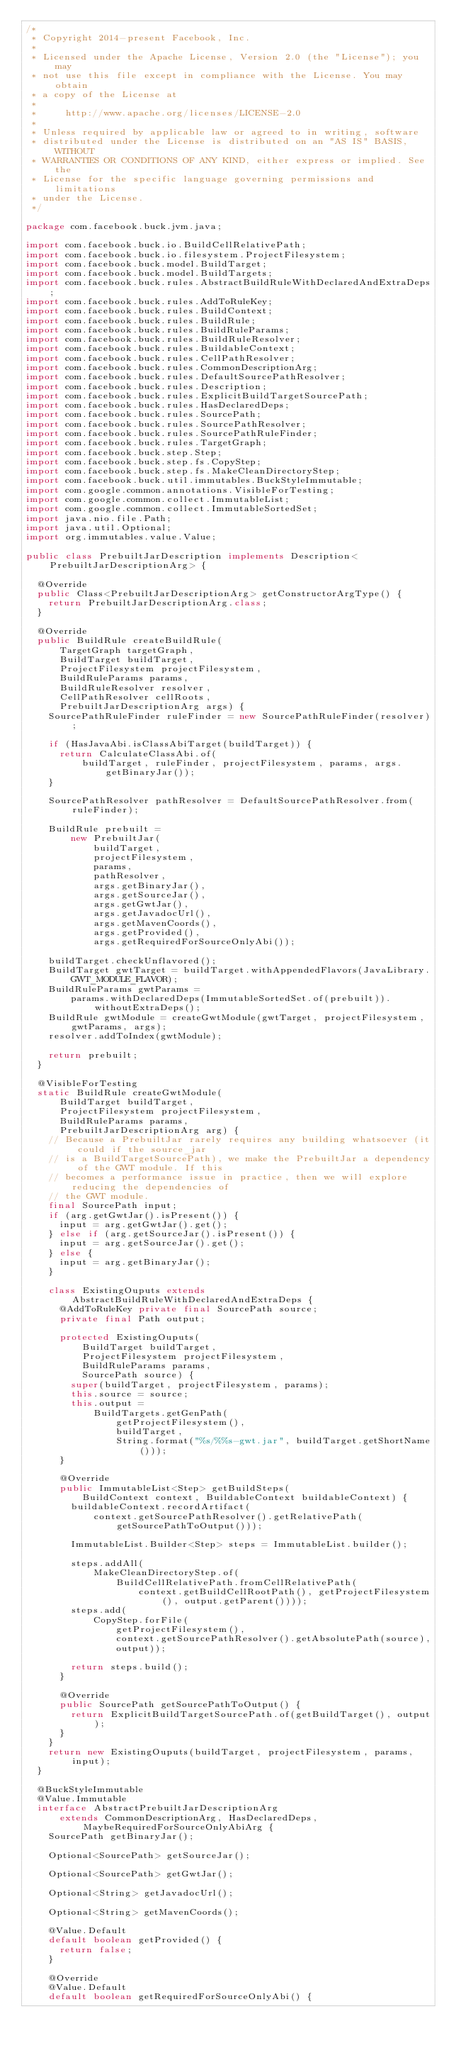Convert code to text. <code><loc_0><loc_0><loc_500><loc_500><_Java_>/*
 * Copyright 2014-present Facebook, Inc.
 *
 * Licensed under the Apache License, Version 2.0 (the "License"); you may
 * not use this file except in compliance with the License. You may obtain
 * a copy of the License at
 *
 *     http://www.apache.org/licenses/LICENSE-2.0
 *
 * Unless required by applicable law or agreed to in writing, software
 * distributed under the License is distributed on an "AS IS" BASIS, WITHOUT
 * WARRANTIES OR CONDITIONS OF ANY KIND, either express or implied. See the
 * License for the specific language governing permissions and limitations
 * under the License.
 */

package com.facebook.buck.jvm.java;

import com.facebook.buck.io.BuildCellRelativePath;
import com.facebook.buck.io.filesystem.ProjectFilesystem;
import com.facebook.buck.model.BuildTarget;
import com.facebook.buck.model.BuildTargets;
import com.facebook.buck.rules.AbstractBuildRuleWithDeclaredAndExtraDeps;
import com.facebook.buck.rules.AddToRuleKey;
import com.facebook.buck.rules.BuildContext;
import com.facebook.buck.rules.BuildRule;
import com.facebook.buck.rules.BuildRuleParams;
import com.facebook.buck.rules.BuildRuleResolver;
import com.facebook.buck.rules.BuildableContext;
import com.facebook.buck.rules.CellPathResolver;
import com.facebook.buck.rules.CommonDescriptionArg;
import com.facebook.buck.rules.DefaultSourcePathResolver;
import com.facebook.buck.rules.Description;
import com.facebook.buck.rules.ExplicitBuildTargetSourcePath;
import com.facebook.buck.rules.HasDeclaredDeps;
import com.facebook.buck.rules.SourcePath;
import com.facebook.buck.rules.SourcePathResolver;
import com.facebook.buck.rules.SourcePathRuleFinder;
import com.facebook.buck.rules.TargetGraph;
import com.facebook.buck.step.Step;
import com.facebook.buck.step.fs.CopyStep;
import com.facebook.buck.step.fs.MakeCleanDirectoryStep;
import com.facebook.buck.util.immutables.BuckStyleImmutable;
import com.google.common.annotations.VisibleForTesting;
import com.google.common.collect.ImmutableList;
import com.google.common.collect.ImmutableSortedSet;
import java.nio.file.Path;
import java.util.Optional;
import org.immutables.value.Value;

public class PrebuiltJarDescription implements Description<PrebuiltJarDescriptionArg> {

  @Override
  public Class<PrebuiltJarDescriptionArg> getConstructorArgType() {
    return PrebuiltJarDescriptionArg.class;
  }

  @Override
  public BuildRule createBuildRule(
      TargetGraph targetGraph,
      BuildTarget buildTarget,
      ProjectFilesystem projectFilesystem,
      BuildRuleParams params,
      BuildRuleResolver resolver,
      CellPathResolver cellRoots,
      PrebuiltJarDescriptionArg args) {
    SourcePathRuleFinder ruleFinder = new SourcePathRuleFinder(resolver);

    if (HasJavaAbi.isClassAbiTarget(buildTarget)) {
      return CalculateClassAbi.of(
          buildTarget, ruleFinder, projectFilesystem, params, args.getBinaryJar());
    }

    SourcePathResolver pathResolver = DefaultSourcePathResolver.from(ruleFinder);

    BuildRule prebuilt =
        new PrebuiltJar(
            buildTarget,
            projectFilesystem,
            params,
            pathResolver,
            args.getBinaryJar(),
            args.getSourceJar(),
            args.getGwtJar(),
            args.getJavadocUrl(),
            args.getMavenCoords(),
            args.getProvided(),
            args.getRequiredForSourceOnlyAbi());

    buildTarget.checkUnflavored();
    BuildTarget gwtTarget = buildTarget.withAppendedFlavors(JavaLibrary.GWT_MODULE_FLAVOR);
    BuildRuleParams gwtParams =
        params.withDeclaredDeps(ImmutableSortedSet.of(prebuilt)).withoutExtraDeps();
    BuildRule gwtModule = createGwtModule(gwtTarget, projectFilesystem, gwtParams, args);
    resolver.addToIndex(gwtModule);

    return prebuilt;
  }

  @VisibleForTesting
  static BuildRule createGwtModule(
      BuildTarget buildTarget,
      ProjectFilesystem projectFilesystem,
      BuildRuleParams params,
      PrebuiltJarDescriptionArg arg) {
    // Because a PrebuiltJar rarely requires any building whatsoever (it could if the source_jar
    // is a BuildTargetSourcePath), we make the PrebuiltJar a dependency of the GWT module. If this
    // becomes a performance issue in practice, then we will explore reducing the dependencies of
    // the GWT module.
    final SourcePath input;
    if (arg.getGwtJar().isPresent()) {
      input = arg.getGwtJar().get();
    } else if (arg.getSourceJar().isPresent()) {
      input = arg.getSourceJar().get();
    } else {
      input = arg.getBinaryJar();
    }

    class ExistingOuputs extends AbstractBuildRuleWithDeclaredAndExtraDeps {
      @AddToRuleKey private final SourcePath source;
      private final Path output;

      protected ExistingOuputs(
          BuildTarget buildTarget,
          ProjectFilesystem projectFilesystem,
          BuildRuleParams params,
          SourcePath source) {
        super(buildTarget, projectFilesystem, params);
        this.source = source;
        this.output =
            BuildTargets.getGenPath(
                getProjectFilesystem(),
                buildTarget,
                String.format("%s/%%s-gwt.jar", buildTarget.getShortName()));
      }

      @Override
      public ImmutableList<Step> getBuildSteps(
          BuildContext context, BuildableContext buildableContext) {
        buildableContext.recordArtifact(
            context.getSourcePathResolver().getRelativePath(getSourcePathToOutput()));

        ImmutableList.Builder<Step> steps = ImmutableList.builder();

        steps.addAll(
            MakeCleanDirectoryStep.of(
                BuildCellRelativePath.fromCellRelativePath(
                    context.getBuildCellRootPath(), getProjectFilesystem(), output.getParent())));
        steps.add(
            CopyStep.forFile(
                getProjectFilesystem(),
                context.getSourcePathResolver().getAbsolutePath(source),
                output));

        return steps.build();
      }

      @Override
      public SourcePath getSourcePathToOutput() {
        return ExplicitBuildTargetSourcePath.of(getBuildTarget(), output);
      }
    }
    return new ExistingOuputs(buildTarget, projectFilesystem, params, input);
  }

  @BuckStyleImmutable
  @Value.Immutable
  interface AbstractPrebuiltJarDescriptionArg
      extends CommonDescriptionArg, HasDeclaredDeps, MaybeRequiredForSourceOnlyAbiArg {
    SourcePath getBinaryJar();

    Optional<SourcePath> getSourceJar();

    Optional<SourcePath> getGwtJar();

    Optional<String> getJavadocUrl();

    Optional<String> getMavenCoords();

    @Value.Default
    default boolean getProvided() {
      return false;
    }

    @Override
    @Value.Default
    default boolean getRequiredForSourceOnlyAbi() {</code> 